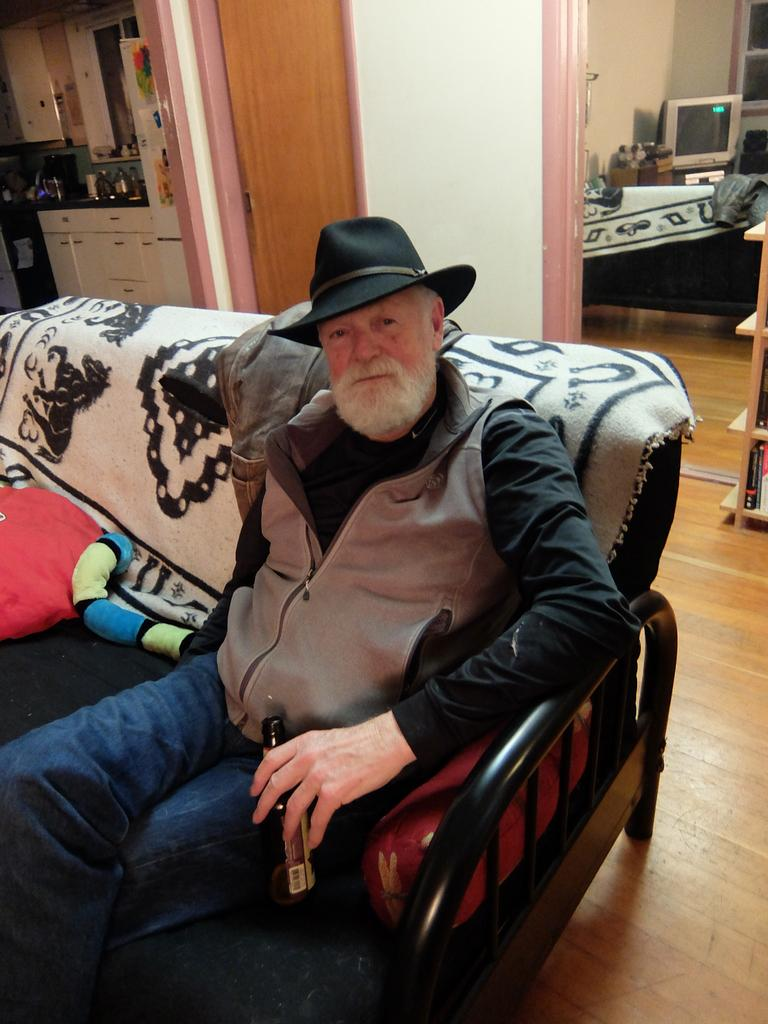What is the man in the image doing? The man is seated on a sofa in the image. What is the man wearing on his head? The man is wearing a cap. What electronic device can be seen in the image? There is a television in the image. What type of furniture is present in the kitchen area? There are cupboards in the kitchen in the image. What type of furniture is present in the bedroom area? There appears to be a bed in the image. What type of winter sport is the man participating in the image? There is no indication of any winter sport or activity in the image; the man is seated on a sofa. How does the man's stomach feel in the image? There is no information about the man's stomach or any emotions in the image. 